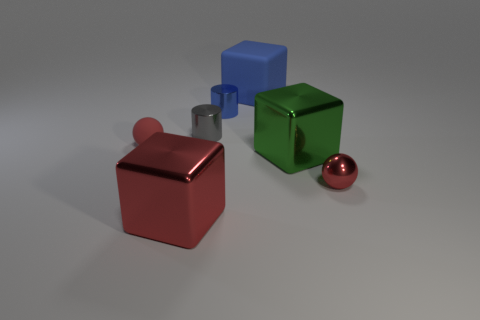Add 3 green spheres. How many objects exist? 10 Subtract all spheres. How many objects are left? 5 Add 4 large shiny blocks. How many large shiny blocks exist? 6 Subtract 0 green cylinders. How many objects are left? 7 Subtract all cyan balls. Subtract all red blocks. How many objects are left? 6 Add 2 matte balls. How many matte balls are left? 3 